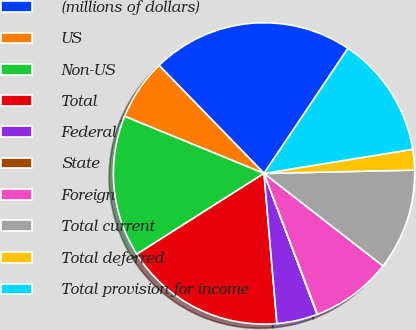Convert chart to OTSL. <chart><loc_0><loc_0><loc_500><loc_500><pie_chart><fcel>(millions of dollars)<fcel>US<fcel>Non-US<fcel>Total<fcel>Federal<fcel>State<fcel>Foreign<fcel>Total current<fcel>Total deferred<fcel>Total provision for income<nl><fcel>21.68%<fcel>6.54%<fcel>15.19%<fcel>17.36%<fcel>4.37%<fcel>0.05%<fcel>8.7%<fcel>10.87%<fcel>2.21%<fcel>13.03%<nl></chart> 